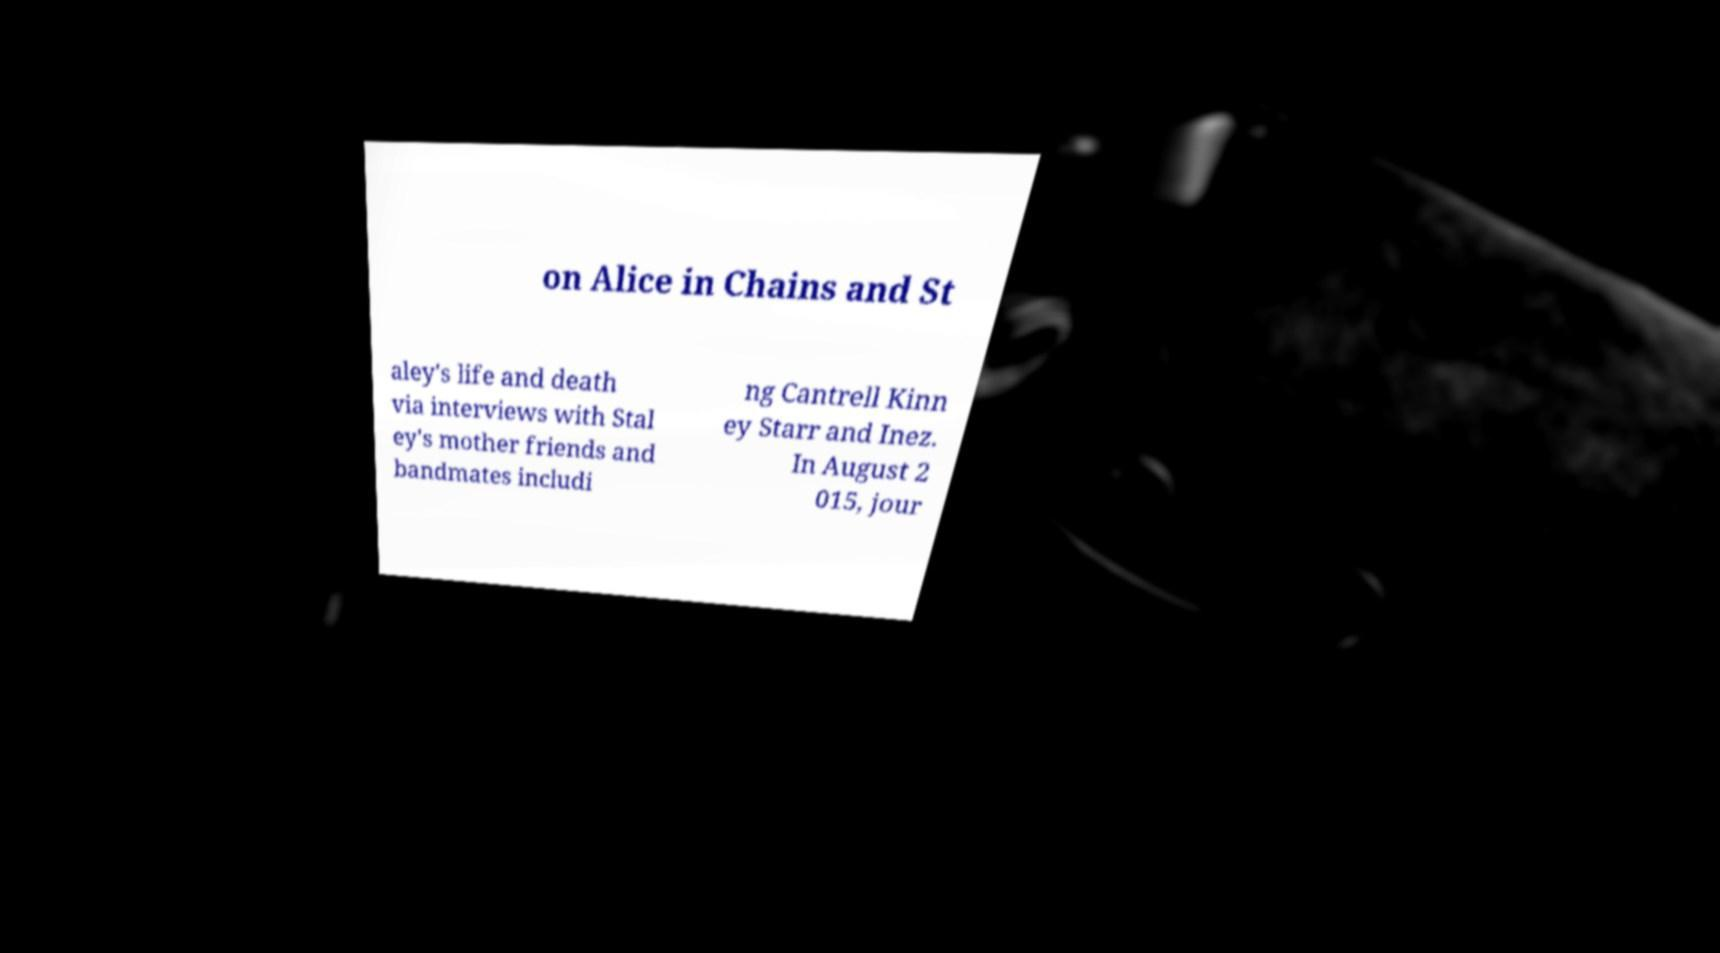There's text embedded in this image that I need extracted. Can you transcribe it verbatim? on Alice in Chains and St aley's life and death via interviews with Stal ey's mother friends and bandmates includi ng Cantrell Kinn ey Starr and Inez. In August 2 015, jour 